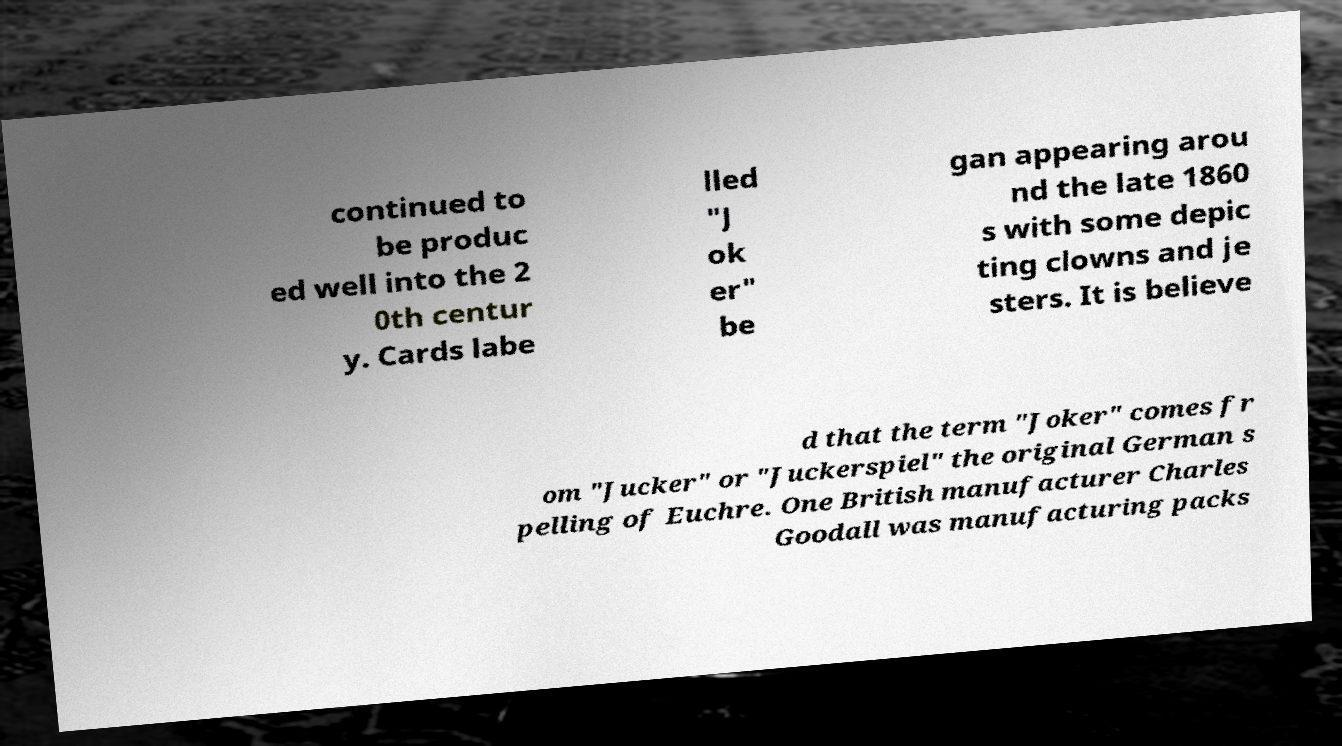What messages or text are displayed in this image? I need them in a readable, typed format. continued to be produc ed well into the 2 0th centur y. Cards labe lled "J ok er" be gan appearing arou nd the late 1860 s with some depic ting clowns and je sters. It is believe d that the term "Joker" comes fr om "Jucker" or "Juckerspiel" the original German s pelling of Euchre. One British manufacturer Charles Goodall was manufacturing packs 